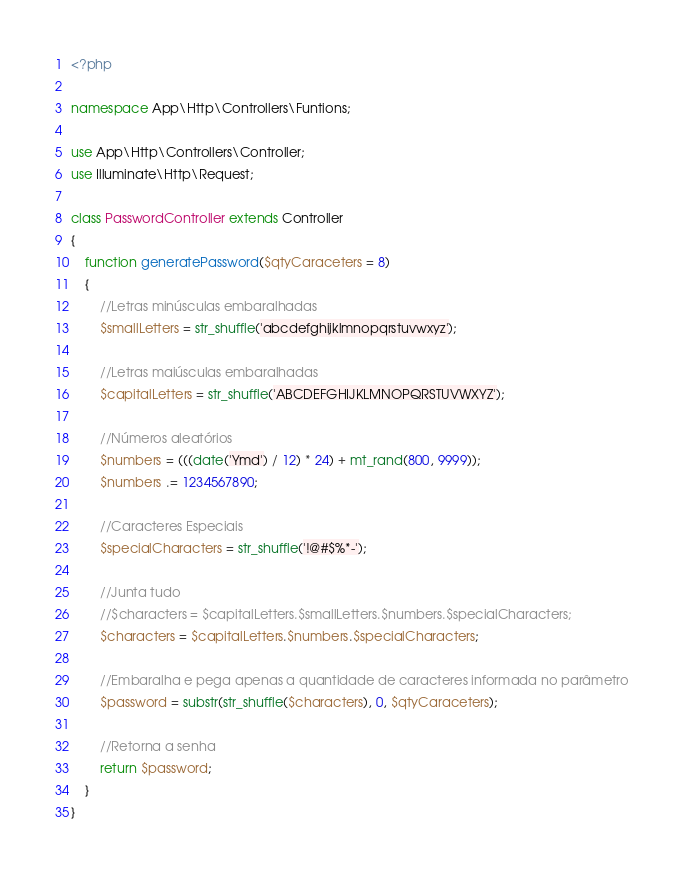<code> <loc_0><loc_0><loc_500><loc_500><_PHP_><?php

namespace App\Http\Controllers\Funtions;

use App\Http\Controllers\Controller;
use Illuminate\Http\Request;

class PasswordController extends Controller
{
    function generatePassword($qtyCaraceters = 8)
    {
        //Letras minúsculas embaralhadas
        $smallLetters = str_shuffle('abcdefghijklmnopqrstuvwxyz');

        //Letras maiúsculas embaralhadas
        $capitalLetters = str_shuffle('ABCDEFGHIJKLMNOPQRSTUVWXYZ');

        //Números aleatórios
        $numbers = (((date('Ymd') / 12) * 24) + mt_rand(800, 9999));
        $numbers .= 1234567890;

        //Caracteres Especiais
        $specialCharacters = str_shuffle('!@#$%*-');

        //Junta tudo
        //$characters = $capitalLetters.$smallLetters.$numbers.$specialCharacters;
        $characters = $capitalLetters.$numbers.$specialCharacters;

        //Embaralha e pega apenas a quantidade de caracteres informada no parâmetro
        $password = substr(str_shuffle($characters), 0, $qtyCaraceters);

        //Retorna a senha
        return $password;
    }
}
</code> 